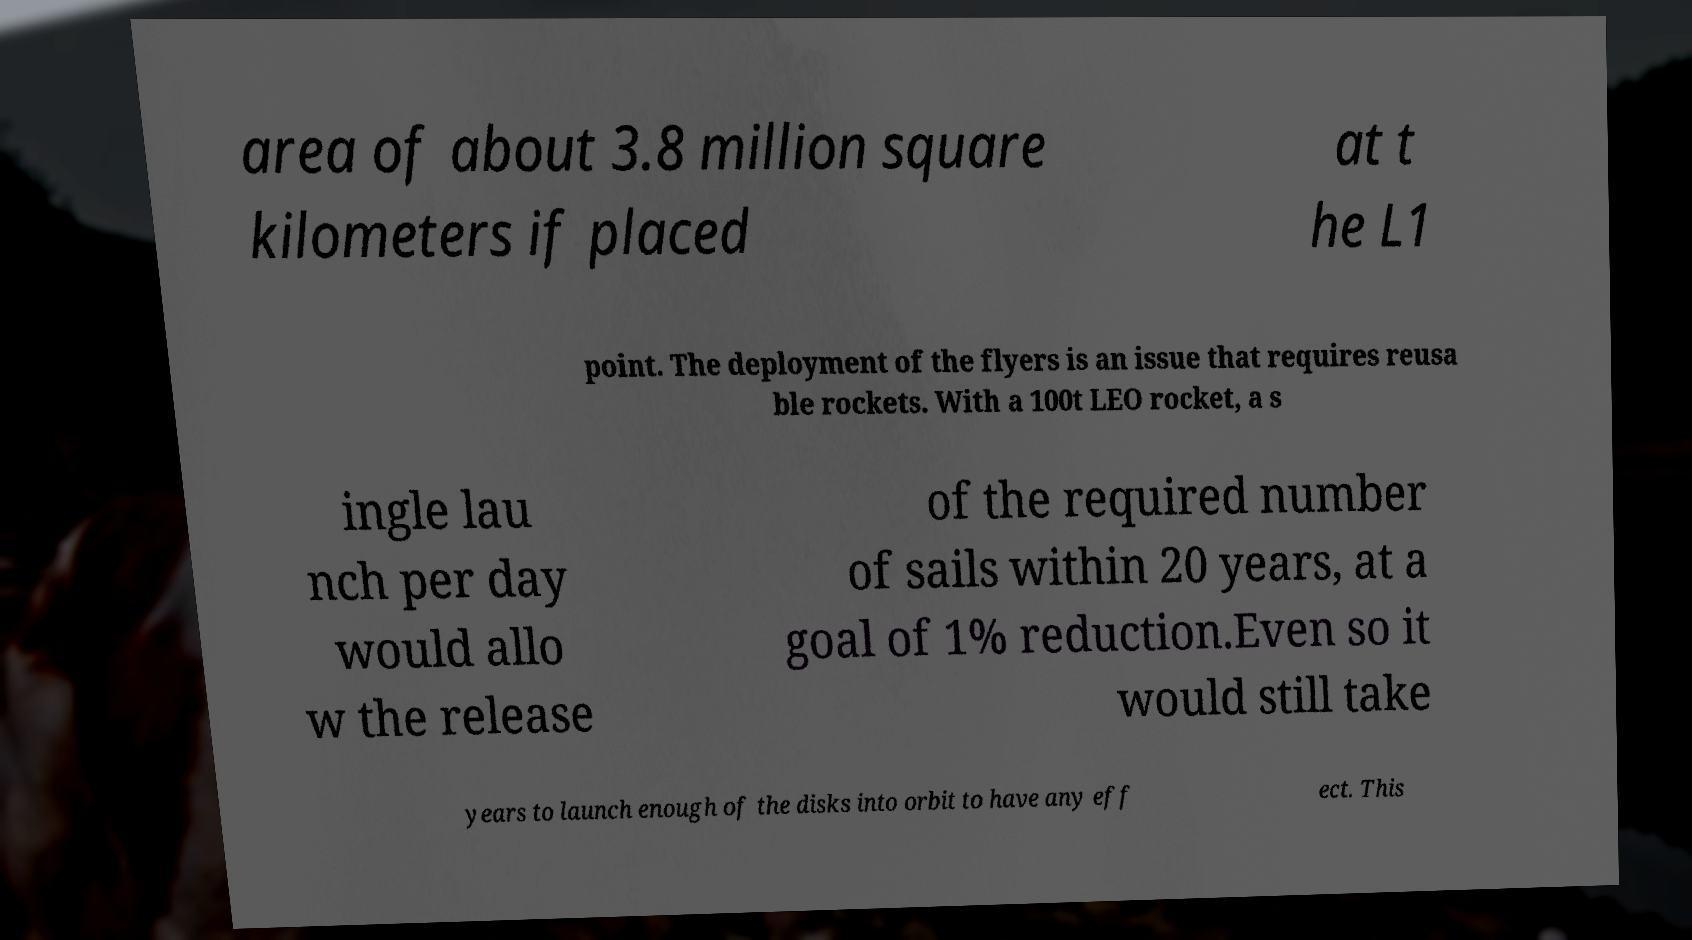Can you accurately transcribe the text from the provided image for me? area of about 3.8 million square kilometers if placed at t he L1 point. The deployment of the flyers is an issue that requires reusa ble rockets. With a 100t LEO rocket, a s ingle lau nch per day would allo w the release of the required number of sails within 20 years, at a goal of 1% reduction.Even so it would still take years to launch enough of the disks into orbit to have any eff ect. This 